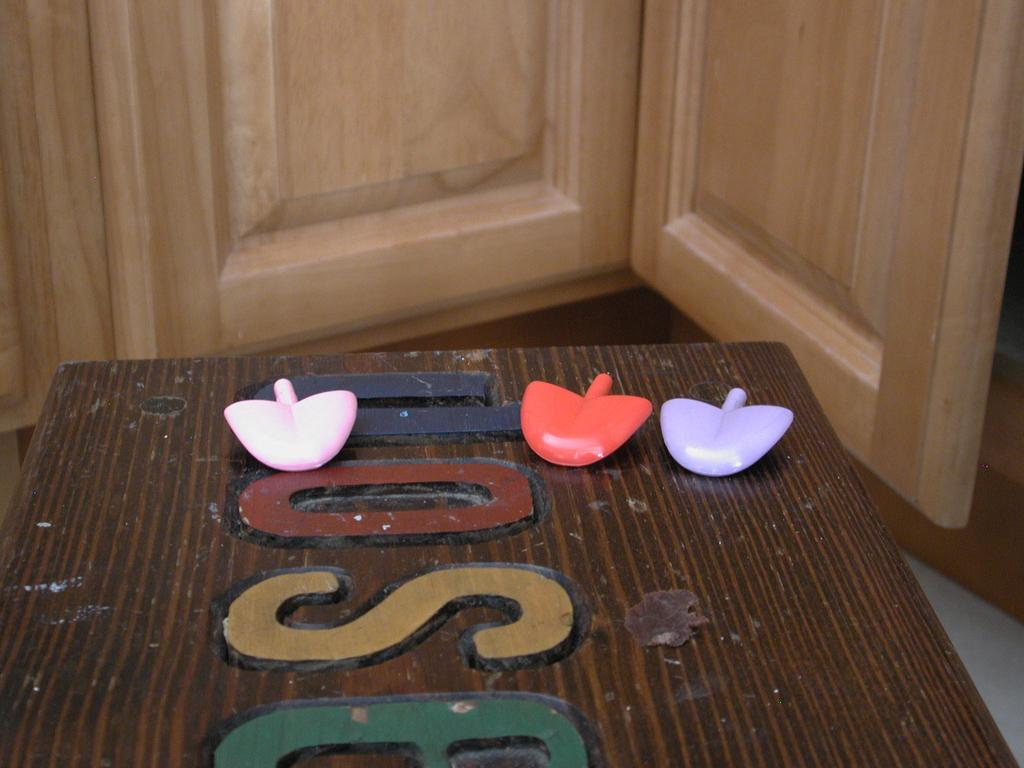What is the main object in the image? There is a table in the image. What is placed on the table? There are three small plastic leaves on the table. Are there any markings or designs on the table? Yes, there is a carving of letters on the table. What can be seen in the background of the image? There is a wooden door in the background of the image. What type of lipstick is the person wearing in the image? There is no person or lipstick present in the image; it features a table with plastic leaves and a carving of letters. 